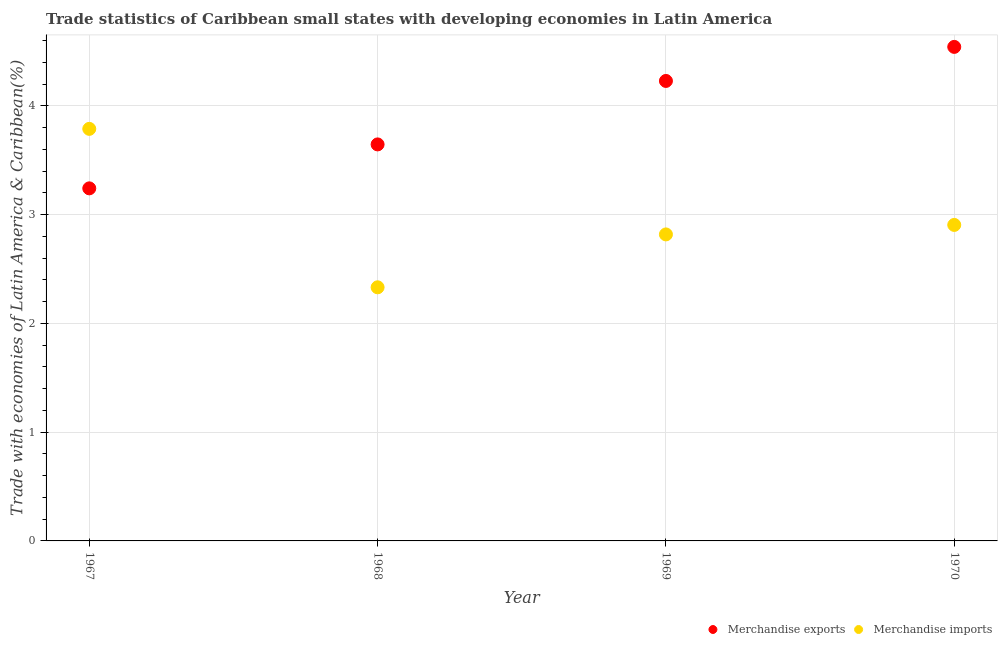What is the merchandise imports in 1967?
Give a very brief answer. 3.79. Across all years, what is the maximum merchandise exports?
Keep it short and to the point. 4.54. Across all years, what is the minimum merchandise exports?
Make the answer very short. 3.24. In which year was the merchandise imports maximum?
Your answer should be compact. 1967. In which year was the merchandise imports minimum?
Provide a succinct answer. 1968. What is the total merchandise exports in the graph?
Your answer should be compact. 15.66. What is the difference between the merchandise exports in 1967 and that in 1969?
Your response must be concise. -0.99. What is the difference between the merchandise imports in 1969 and the merchandise exports in 1970?
Offer a very short reply. -1.72. What is the average merchandise imports per year?
Provide a succinct answer. 2.96. In the year 1970, what is the difference between the merchandise exports and merchandise imports?
Provide a short and direct response. 1.64. In how many years, is the merchandise imports greater than 2.4 %?
Keep it short and to the point. 3. What is the ratio of the merchandise imports in 1969 to that in 1970?
Your answer should be compact. 0.97. What is the difference between the highest and the second highest merchandise exports?
Provide a short and direct response. 0.31. What is the difference between the highest and the lowest merchandise imports?
Provide a short and direct response. 1.46. In how many years, is the merchandise exports greater than the average merchandise exports taken over all years?
Provide a succinct answer. 2. Is the sum of the merchandise exports in 1967 and 1968 greater than the maximum merchandise imports across all years?
Your response must be concise. Yes. Is the merchandise imports strictly less than the merchandise exports over the years?
Offer a terse response. No. How many years are there in the graph?
Your response must be concise. 4. What is the difference between two consecutive major ticks on the Y-axis?
Provide a succinct answer. 1. Are the values on the major ticks of Y-axis written in scientific E-notation?
Provide a succinct answer. No. Does the graph contain grids?
Provide a succinct answer. Yes. Where does the legend appear in the graph?
Give a very brief answer. Bottom right. How many legend labels are there?
Your answer should be very brief. 2. What is the title of the graph?
Your response must be concise. Trade statistics of Caribbean small states with developing economies in Latin America. What is the label or title of the X-axis?
Make the answer very short. Year. What is the label or title of the Y-axis?
Offer a very short reply. Trade with economies of Latin America & Caribbean(%). What is the Trade with economies of Latin America & Caribbean(%) in Merchandise exports in 1967?
Give a very brief answer. 3.24. What is the Trade with economies of Latin America & Caribbean(%) of Merchandise imports in 1967?
Your answer should be very brief. 3.79. What is the Trade with economies of Latin America & Caribbean(%) of Merchandise exports in 1968?
Provide a short and direct response. 3.65. What is the Trade with economies of Latin America & Caribbean(%) in Merchandise imports in 1968?
Ensure brevity in your answer.  2.33. What is the Trade with economies of Latin America & Caribbean(%) of Merchandise exports in 1969?
Provide a short and direct response. 4.23. What is the Trade with economies of Latin America & Caribbean(%) of Merchandise imports in 1969?
Offer a terse response. 2.82. What is the Trade with economies of Latin America & Caribbean(%) of Merchandise exports in 1970?
Make the answer very short. 4.54. What is the Trade with economies of Latin America & Caribbean(%) in Merchandise imports in 1970?
Ensure brevity in your answer.  2.91. Across all years, what is the maximum Trade with economies of Latin America & Caribbean(%) of Merchandise exports?
Make the answer very short. 4.54. Across all years, what is the maximum Trade with economies of Latin America & Caribbean(%) of Merchandise imports?
Keep it short and to the point. 3.79. Across all years, what is the minimum Trade with economies of Latin America & Caribbean(%) in Merchandise exports?
Provide a succinct answer. 3.24. Across all years, what is the minimum Trade with economies of Latin America & Caribbean(%) of Merchandise imports?
Your answer should be compact. 2.33. What is the total Trade with economies of Latin America & Caribbean(%) of Merchandise exports in the graph?
Give a very brief answer. 15.66. What is the total Trade with economies of Latin America & Caribbean(%) in Merchandise imports in the graph?
Your answer should be very brief. 11.85. What is the difference between the Trade with economies of Latin America & Caribbean(%) of Merchandise exports in 1967 and that in 1968?
Provide a short and direct response. -0.4. What is the difference between the Trade with economies of Latin America & Caribbean(%) of Merchandise imports in 1967 and that in 1968?
Offer a terse response. 1.46. What is the difference between the Trade with economies of Latin America & Caribbean(%) in Merchandise exports in 1967 and that in 1969?
Provide a succinct answer. -0.99. What is the difference between the Trade with economies of Latin America & Caribbean(%) of Merchandise imports in 1967 and that in 1969?
Provide a short and direct response. 0.97. What is the difference between the Trade with economies of Latin America & Caribbean(%) in Merchandise exports in 1967 and that in 1970?
Make the answer very short. -1.3. What is the difference between the Trade with economies of Latin America & Caribbean(%) of Merchandise imports in 1967 and that in 1970?
Ensure brevity in your answer.  0.88. What is the difference between the Trade with economies of Latin America & Caribbean(%) of Merchandise exports in 1968 and that in 1969?
Keep it short and to the point. -0.58. What is the difference between the Trade with economies of Latin America & Caribbean(%) in Merchandise imports in 1968 and that in 1969?
Provide a short and direct response. -0.49. What is the difference between the Trade with economies of Latin America & Caribbean(%) in Merchandise exports in 1968 and that in 1970?
Your answer should be very brief. -0.9. What is the difference between the Trade with economies of Latin America & Caribbean(%) of Merchandise imports in 1968 and that in 1970?
Your answer should be very brief. -0.57. What is the difference between the Trade with economies of Latin America & Caribbean(%) in Merchandise exports in 1969 and that in 1970?
Ensure brevity in your answer.  -0.31. What is the difference between the Trade with economies of Latin America & Caribbean(%) in Merchandise imports in 1969 and that in 1970?
Provide a short and direct response. -0.09. What is the difference between the Trade with economies of Latin America & Caribbean(%) of Merchandise exports in 1967 and the Trade with economies of Latin America & Caribbean(%) of Merchandise imports in 1968?
Your response must be concise. 0.91. What is the difference between the Trade with economies of Latin America & Caribbean(%) of Merchandise exports in 1967 and the Trade with economies of Latin America & Caribbean(%) of Merchandise imports in 1969?
Offer a terse response. 0.42. What is the difference between the Trade with economies of Latin America & Caribbean(%) in Merchandise exports in 1967 and the Trade with economies of Latin America & Caribbean(%) in Merchandise imports in 1970?
Your answer should be compact. 0.34. What is the difference between the Trade with economies of Latin America & Caribbean(%) in Merchandise exports in 1968 and the Trade with economies of Latin America & Caribbean(%) in Merchandise imports in 1969?
Your answer should be compact. 0.83. What is the difference between the Trade with economies of Latin America & Caribbean(%) of Merchandise exports in 1968 and the Trade with economies of Latin America & Caribbean(%) of Merchandise imports in 1970?
Give a very brief answer. 0.74. What is the difference between the Trade with economies of Latin America & Caribbean(%) of Merchandise exports in 1969 and the Trade with economies of Latin America & Caribbean(%) of Merchandise imports in 1970?
Make the answer very short. 1.32. What is the average Trade with economies of Latin America & Caribbean(%) of Merchandise exports per year?
Your answer should be very brief. 3.92. What is the average Trade with economies of Latin America & Caribbean(%) of Merchandise imports per year?
Offer a terse response. 2.96. In the year 1967, what is the difference between the Trade with economies of Latin America & Caribbean(%) of Merchandise exports and Trade with economies of Latin America & Caribbean(%) of Merchandise imports?
Keep it short and to the point. -0.55. In the year 1968, what is the difference between the Trade with economies of Latin America & Caribbean(%) of Merchandise exports and Trade with economies of Latin America & Caribbean(%) of Merchandise imports?
Keep it short and to the point. 1.31. In the year 1969, what is the difference between the Trade with economies of Latin America & Caribbean(%) of Merchandise exports and Trade with economies of Latin America & Caribbean(%) of Merchandise imports?
Make the answer very short. 1.41. In the year 1970, what is the difference between the Trade with economies of Latin America & Caribbean(%) in Merchandise exports and Trade with economies of Latin America & Caribbean(%) in Merchandise imports?
Offer a very short reply. 1.64. What is the ratio of the Trade with economies of Latin America & Caribbean(%) in Merchandise exports in 1967 to that in 1968?
Offer a very short reply. 0.89. What is the ratio of the Trade with economies of Latin America & Caribbean(%) of Merchandise imports in 1967 to that in 1968?
Offer a very short reply. 1.62. What is the ratio of the Trade with economies of Latin America & Caribbean(%) in Merchandise exports in 1967 to that in 1969?
Offer a terse response. 0.77. What is the ratio of the Trade with economies of Latin America & Caribbean(%) in Merchandise imports in 1967 to that in 1969?
Your answer should be compact. 1.34. What is the ratio of the Trade with economies of Latin America & Caribbean(%) of Merchandise exports in 1967 to that in 1970?
Provide a short and direct response. 0.71. What is the ratio of the Trade with economies of Latin America & Caribbean(%) of Merchandise imports in 1967 to that in 1970?
Ensure brevity in your answer.  1.3. What is the ratio of the Trade with economies of Latin America & Caribbean(%) of Merchandise exports in 1968 to that in 1969?
Keep it short and to the point. 0.86. What is the ratio of the Trade with economies of Latin America & Caribbean(%) of Merchandise imports in 1968 to that in 1969?
Your answer should be very brief. 0.83. What is the ratio of the Trade with economies of Latin America & Caribbean(%) in Merchandise exports in 1968 to that in 1970?
Make the answer very short. 0.8. What is the ratio of the Trade with economies of Latin America & Caribbean(%) in Merchandise imports in 1968 to that in 1970?
Give a very brief answer. 0.8. What is the ratio of the Trade with economies of Latin America & Caribbean(%) in Merchandise exports in 1969 to that in 1970?
Offer a terse response. 0.93. What is the ratio of the Trade with economies of Latin America & Caribbean(%) of Merchandise imports in 1969 to that in 1970?
Offer a terse response. 0.97. What is the difference between the highest and the second highest Trade with economies of Latin America & Caribbean(%) of Merchandise exports?
Your answer should be compact. 0.31. What is the difference between the highest and the second highest Trade with economies of Latin America & Caribbean(%) in Merchandise imports?
Keep it short and to the point. 0.88. What is the difference between the highest and the lowest Trade with economies of Latin America & Caribbean(%) in Merchandise exports?
Provide a short and direct response. 1.3. What is the difference between the highest and the lowest Trade with economies of Latin America & Caribbean(%) in Merchandise imports?
Provide a short and direct response. 1.46. 